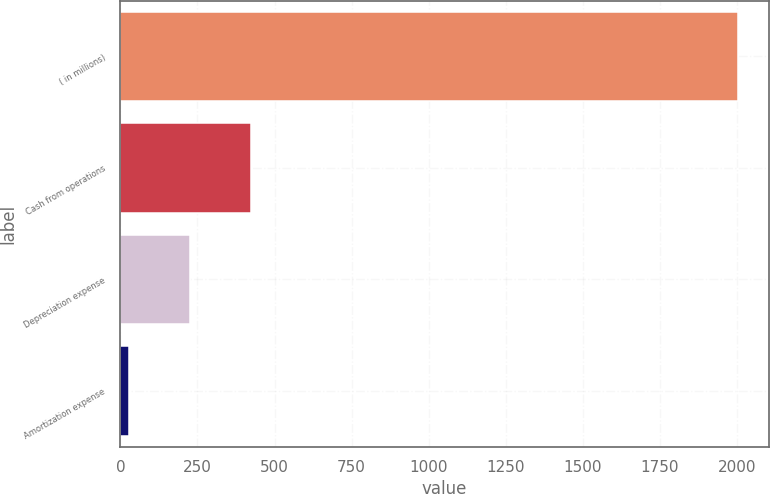Convert chart. <chart><loc_0><loc_0><loc_500><loc_500><bar_chart><fcel>( in millions)<fcel>Cash from operations<fcel>Depreciation expense<fcel>Amortization expense<nl><fcel>2003<fcel>423<fcel>225.5<fcel>28<nl></chart> 